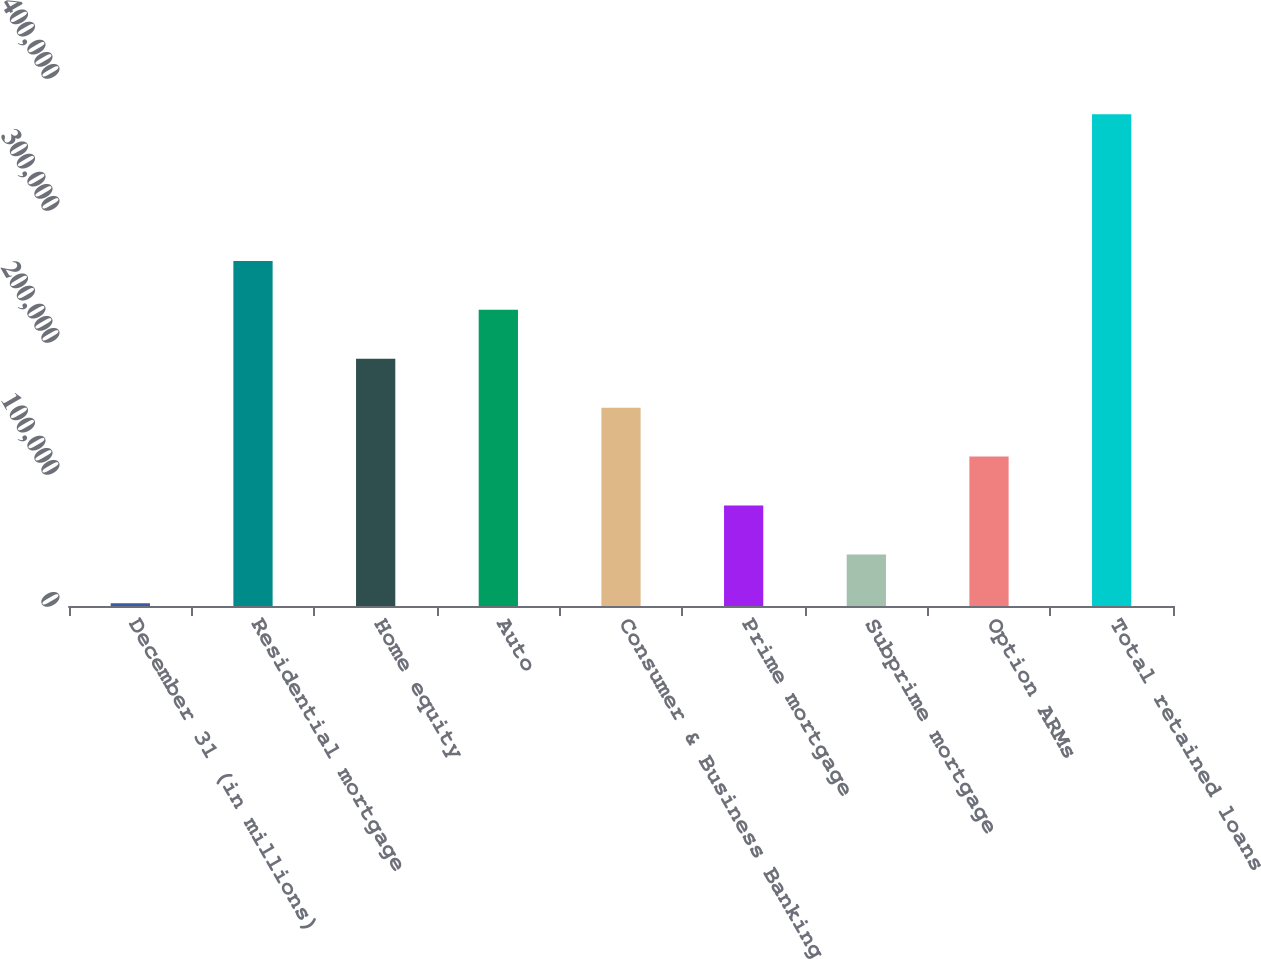<chart> <loc_0><loc_0><loc_500><loc_500><bar_chart><fcel>December 31 (in millions)<fcel>Residential mortgage<fcel>Home equity<fcel>Auto<fcel>Consumer & Business Banking<fcel>Prime mortgage<fcel>Subprime mortgage<fcel>Option ARMs<fcel>Total retained loans<nl><fcel>2017<fcel>261392<fcel>187285<fcel>224339<fcel>150231<fcel>76124.2<fcel>39070.6<fcel>113178<fcel>372553<nl></chart> 